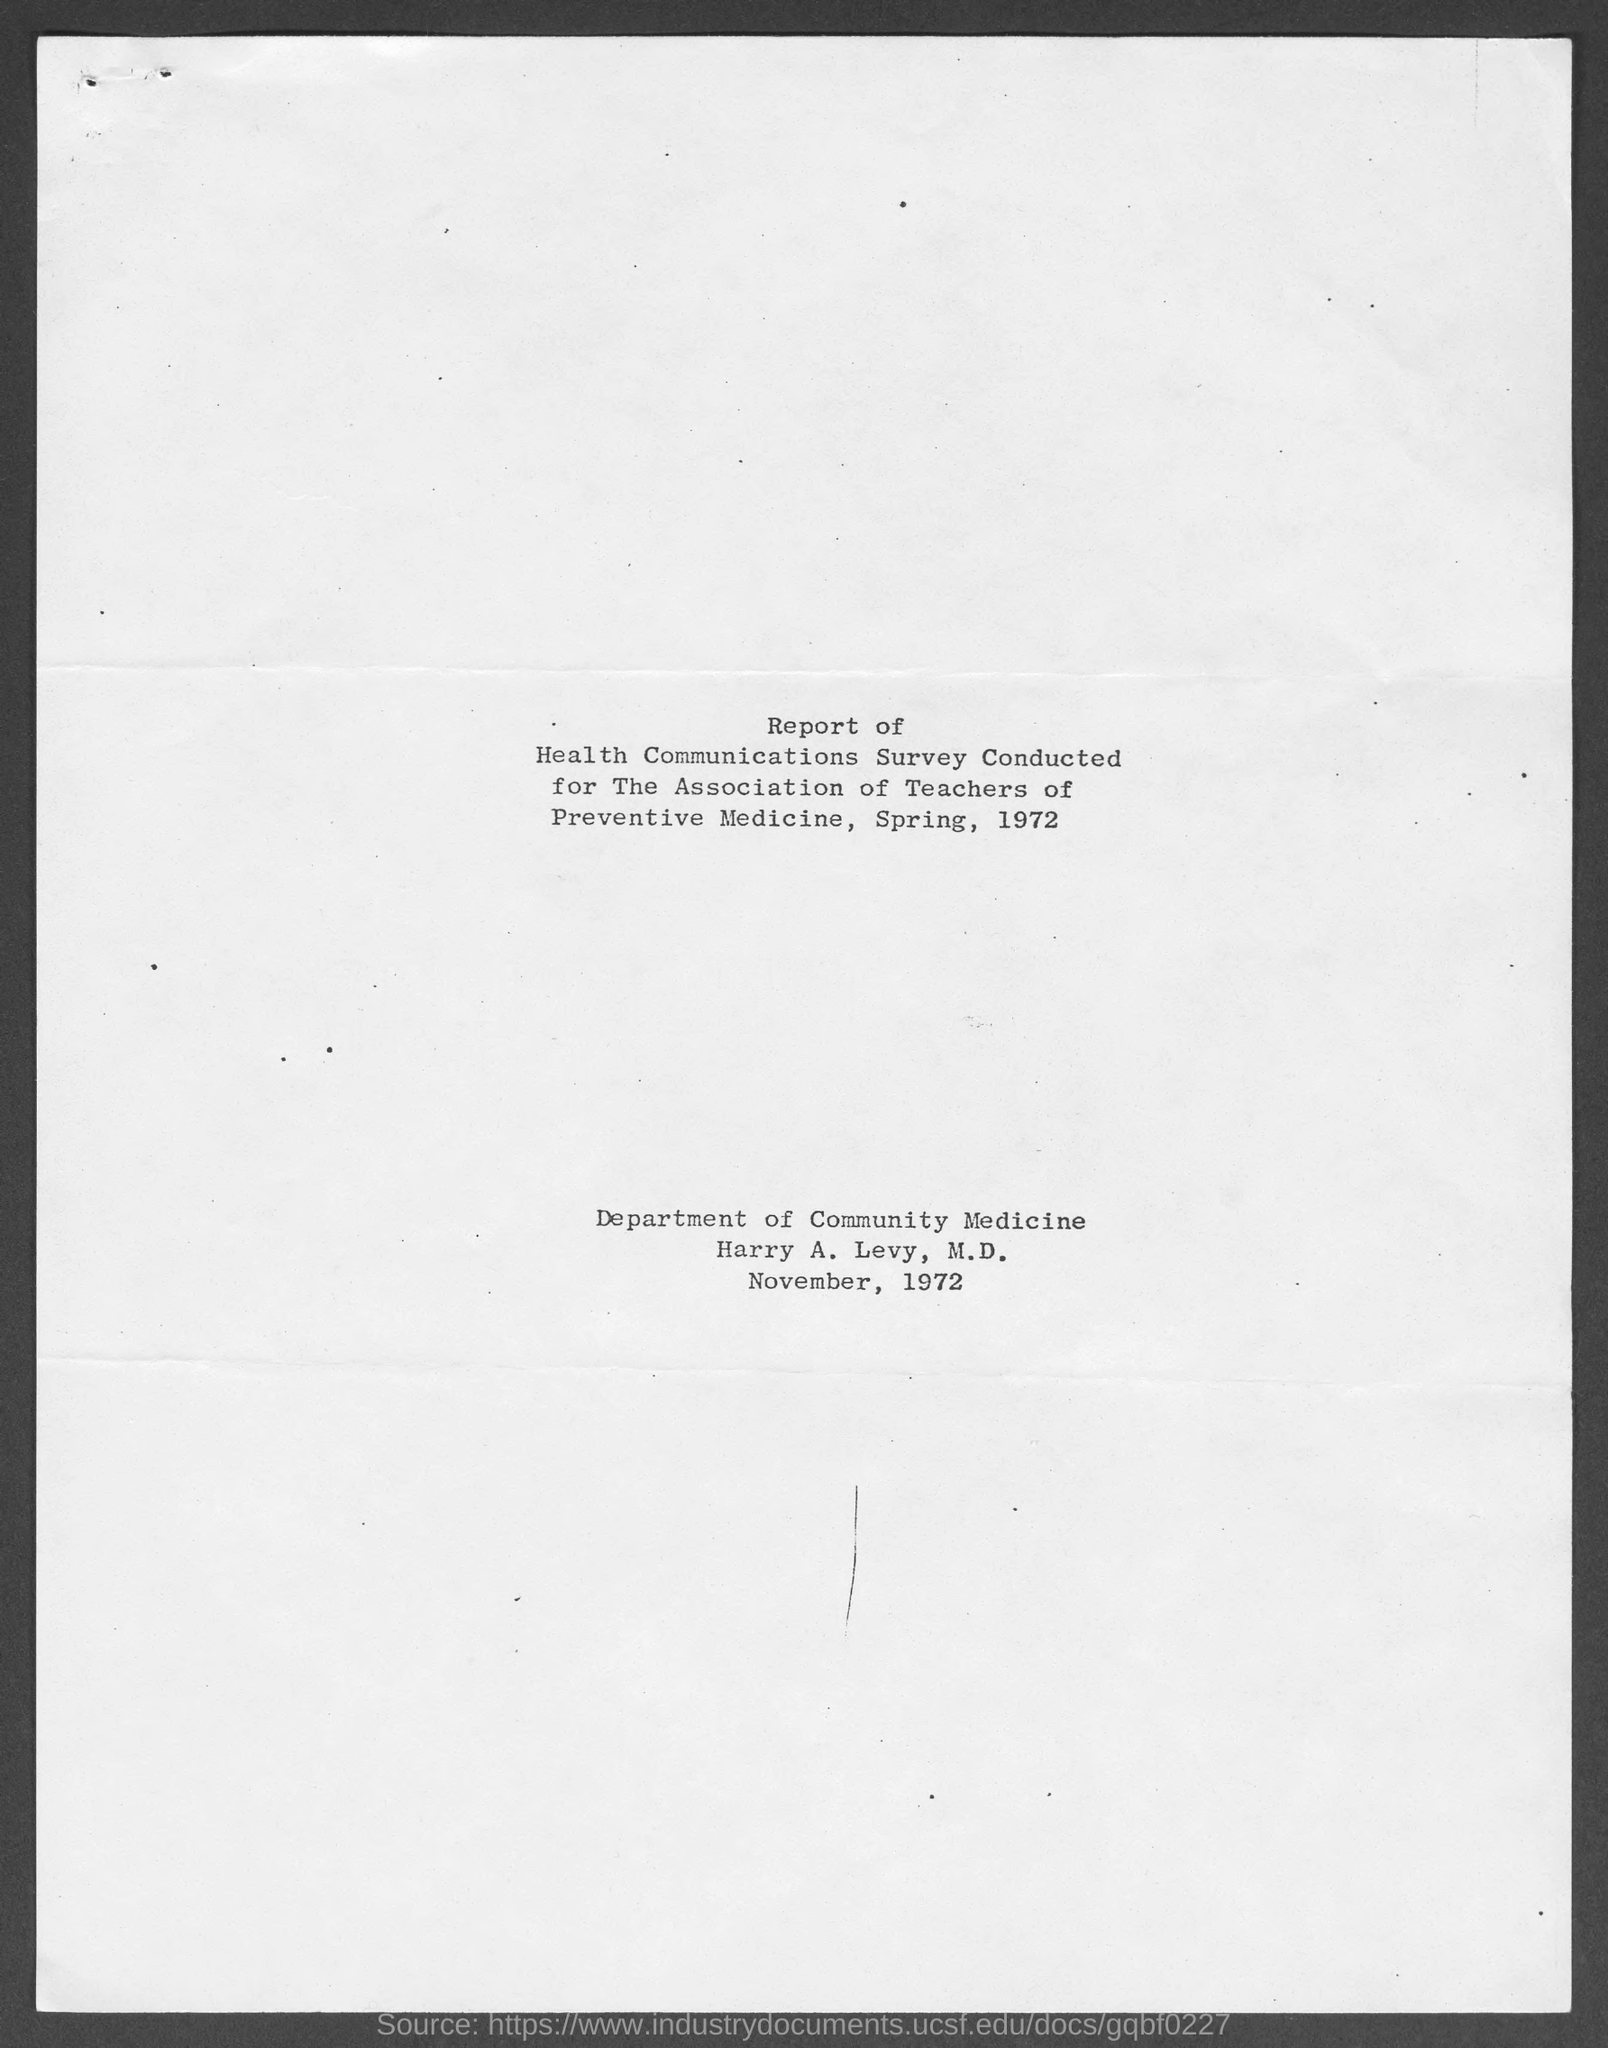In which year, does this report was published?
Your response must be concise. 1972. Which department publish the report ?
Ensure brevity in your answer.  Department of Community Medicine. In which month, the report was published ?
Provide a short and direct response. November. 